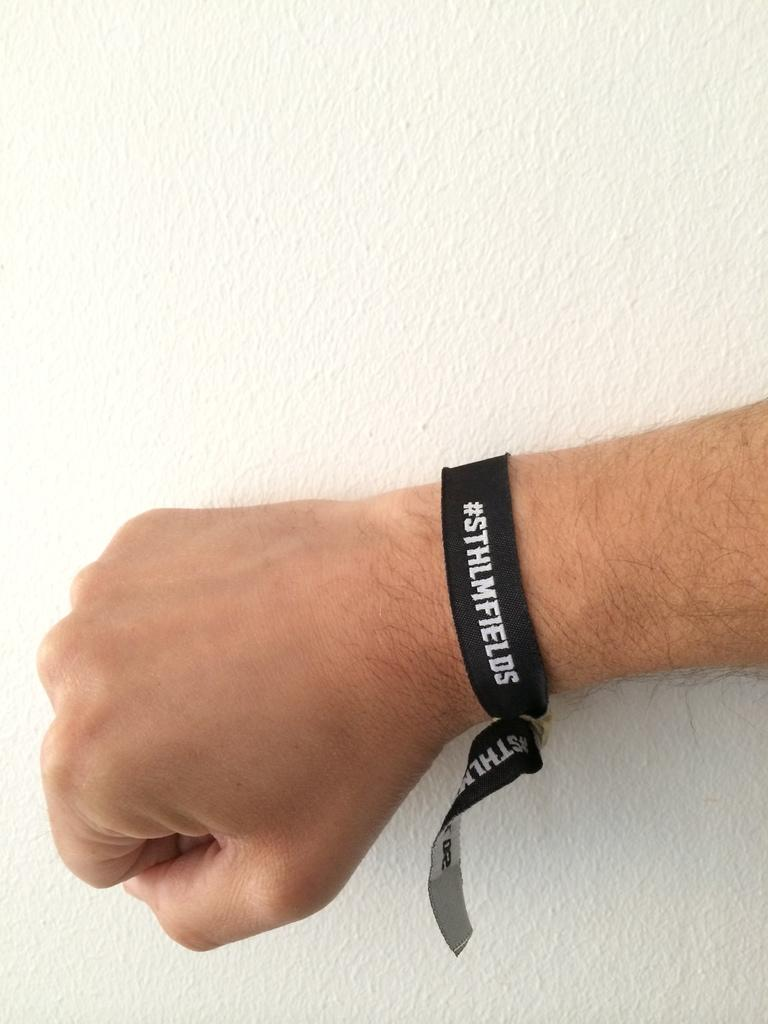What is visible in the image? There is a hand visible in the image. To whom does the hand belong? The hand belongs to a person. What is notable about the person's hand? The person is wearing a band on their hand. How many crates are stacked behind the person's hand in the image? There is no crate visible in the image. What type of straw is being used by the person in the image? There is no straw present in the image. 